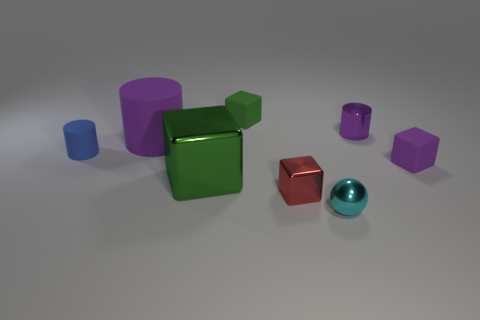What number of blue matte objects are the same shape as the tiny purple matte object? 0 